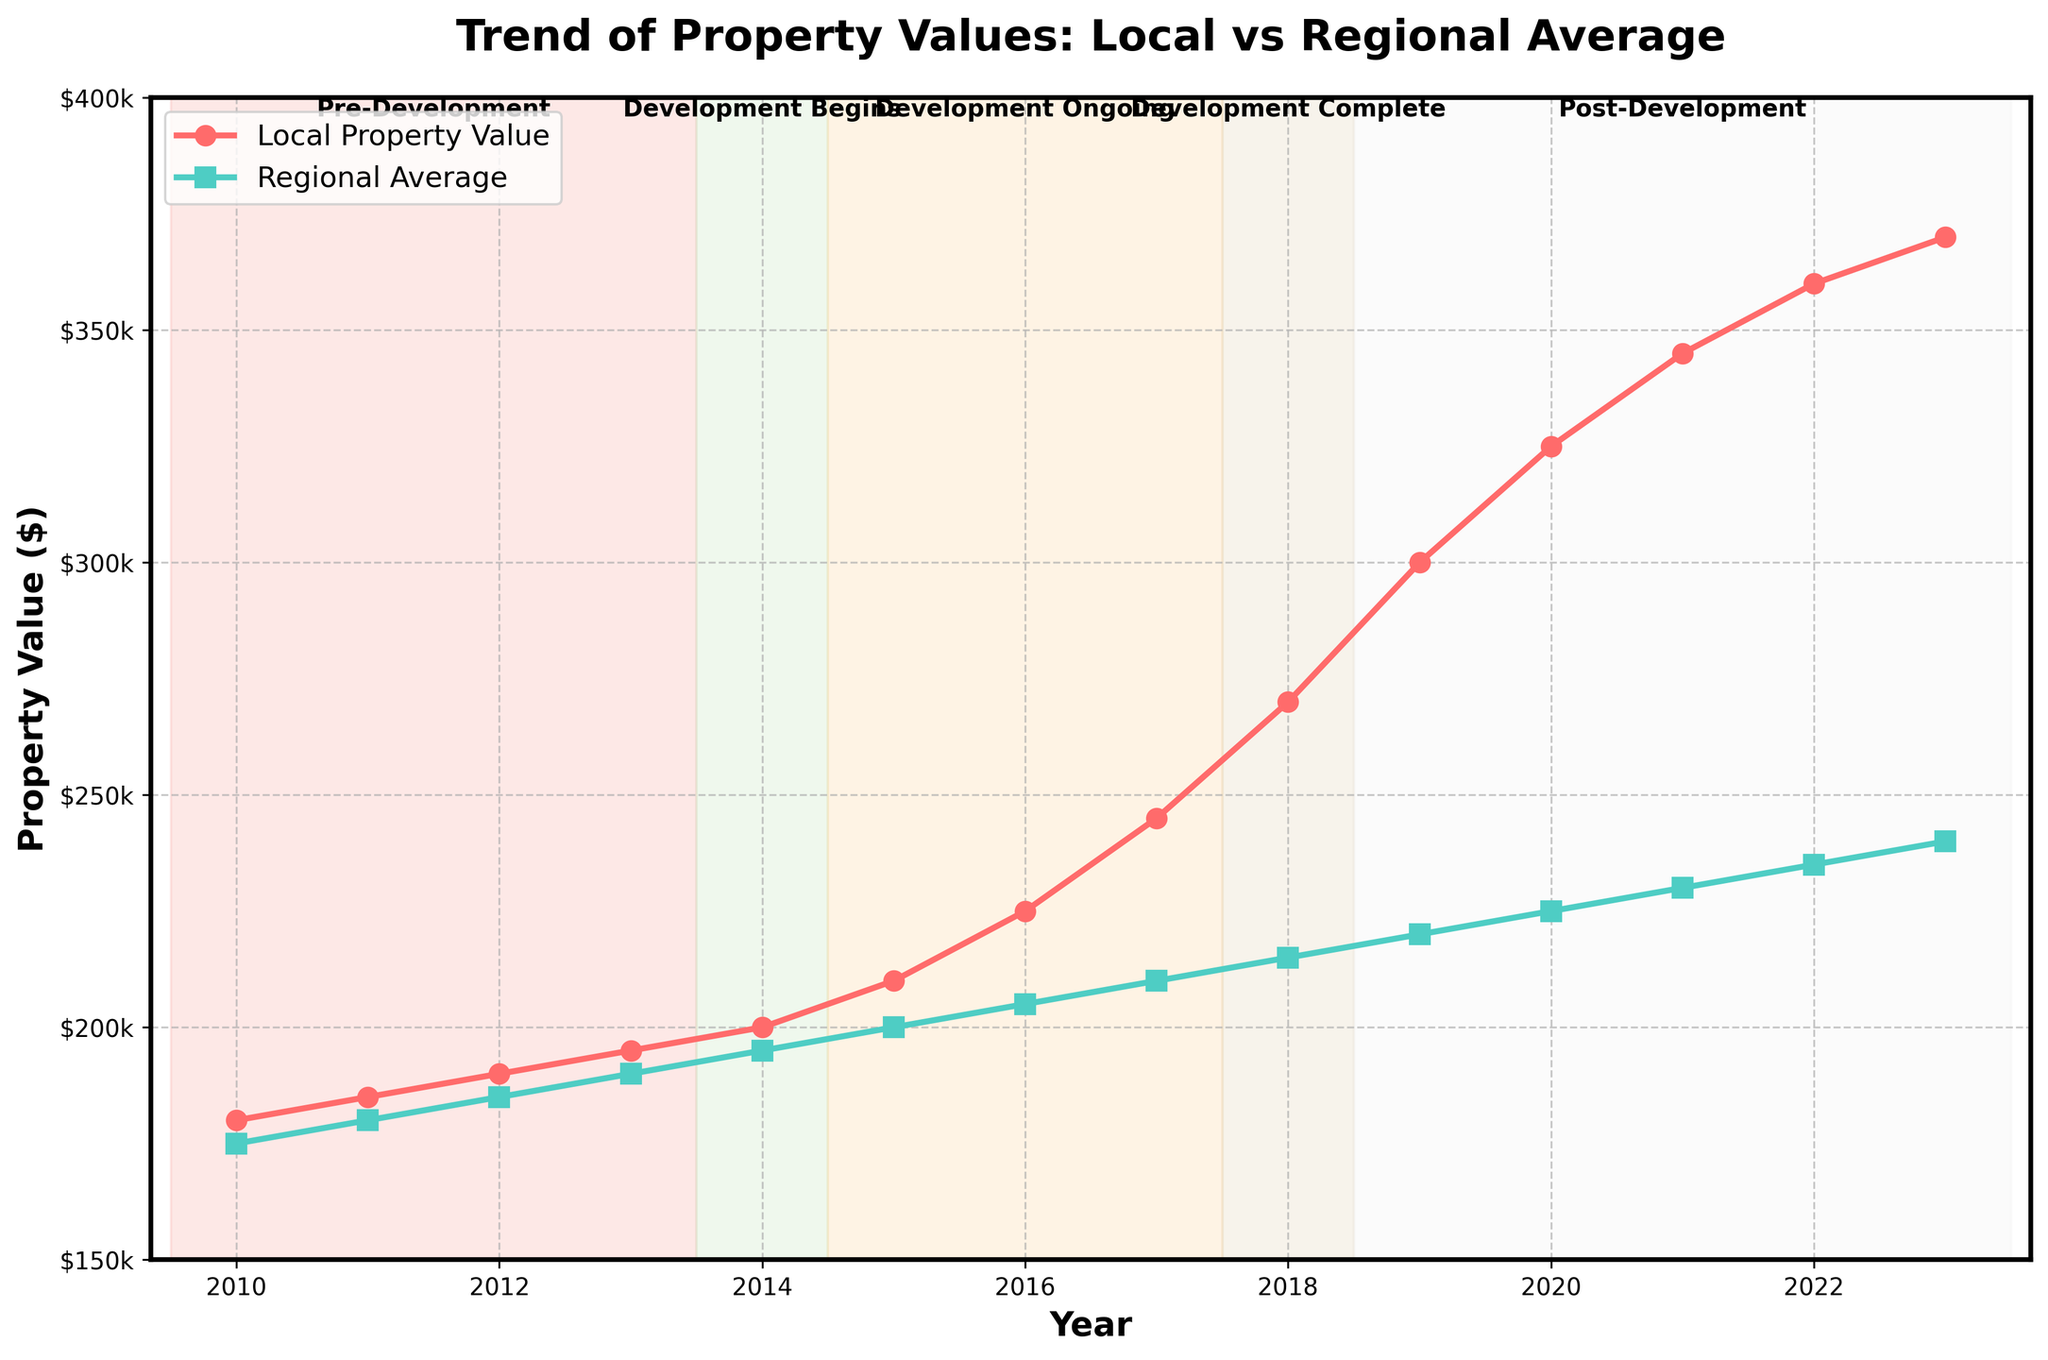What is the property value in the year 2017 for both the local area and the regional average? From the figure, locate the year 2017 on the x-axis. The property value for the local area in 2017 is the corresponding y-value on the red line, which is $245,000, and for the regional average, it’s the corresponding y-value on the green line, which is $210,000.
Answer: Local: $245,000, Regional: $210,000 How much did the local property value increase from 2014 to 2018? Find the property value in 2014 and 2018 on the red line, which are $200,000 and $270,000, respectively. Subtract the value in 2014 from that in 2018: $270,000 - $200,000 = $70,000.
Answer: $70,000 By how much did the local property value increase from the pre-development stage to when the development was complete? The pre-development stage is from 2010 to 2013, with property values ranging from $180,000 to $195,000. The development was complete in 2018 with a property value of $270,000. Subtract the highest pre-development value ($195,000) from the value in 2018: $270,000 - $195,000 = $75,000.
Answer: $75,000 What is the trend in local property values compared to the regional average after the development is completed (2018 onwards)? Post-development, observe the incline of the red line (local property value) and the green line (regional average). The red line shows a significant increase, whereas the green line shows a steady but smaller increase. Thus, local property values rise sharply compared to the regional average.
Answer: Local values increased sharply During the development period (2015-2017), by how much did the local property values change compared to the regional average? The local property values in 2015 and 2017 are $210,000 and $245,000, respectively, resulting in a change of $245,000 - $210,000 = $35,000. For the regional average, values in 2015 and 2017 are $200,000 and $210,000, respectively, resulting in a change of $210,000 - $200,000 = $10,000.
Answer: Local: $35,000, Regional: $10,000 Which year shows the largest gap between local property values and the regional average? From the figure, observe the distance between the red and green lines. The largest gap is in 2023, with local value at $370,000 and regional average at $240,000. Gap = $370,000 - $240,000 = $130,000.
Answer: 2023 What stage of development had the most significant impact on property values locally? The figure highlights different development stages. The biggest rise happens from the period of 'Development Ongoing' spanning until 'Development Complete', specifically from 2016 ($225,000) to 2018 ($270,000). The increase is $270,000 - $225,000 = $45,000.
Answer: Development Ongoing What visual feature distinguishes the different development stages in the figure? The different development stages are distinguished by shaded vertical spans with different colors and labeled text at the top each indicating the stage duration (Pre-Development, Development Begins, Development Ongoing, Development Complete, Post-Development).
Answer: Shaded spans and labels How much higher was the local property value in 2020 compared to the regional average in the same year? From the figure, the year 2020 shows local property value at $325,000 and the regional average at $225,000. Subtract the regional value from the local value: $325,000 - $225,000 = $100,000.
Answer: $100,000 